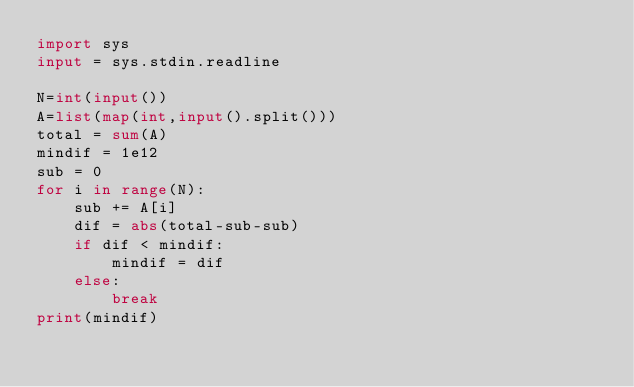Convert code to text. <code><loc_0><loc_0><loc_500><loc_500><_Python_>import sys
input = sys.stdin.readline

N=int(input())
A=list(map(int,input().split()))
total = sum(A)
mindif = 1e12
sub = 0
for i in range(N):
    sub += A[i]
    dif = abs(total-sub-sub)
    if dif < mindif:
        mindif = dif
    else:
        break
print(mindif)

</code> 